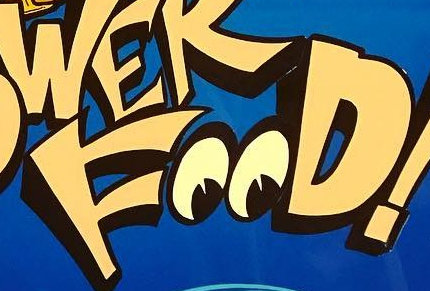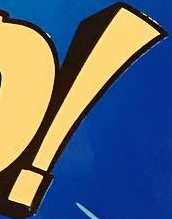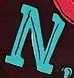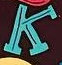Read the text content from these images in order, separated by a semicolon. FOOD; !; N; K 